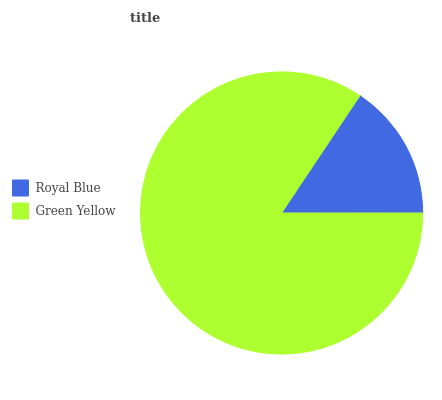Is Royal Blue the minimum?
Answer yes or no. Yes. Is Green Yellow the maximum?
Answer yes or no. Yes. Is Green Yellow the minimum?
Answer yes or no. No. Is Green Yellow greater than Royal Blue?
Answer yes or no. Yes. Is Royal Blue less than Green Yellow?
Answer yes or no. Yes. Is Royal Blue greater than Green Yellow?
Answer yes or no. No. Is Green Yellow less than Royal Blue?
Answer yes or no. No. Is Green Yellow the high median?
Answer yes or no. Yes. Is Royal Blue the low median?
Answer yes or no. Yes. Is Royal Blue the high median?
Answer yes or no. No. Is Green Yellow the low median?
Answer yes or no. No. 